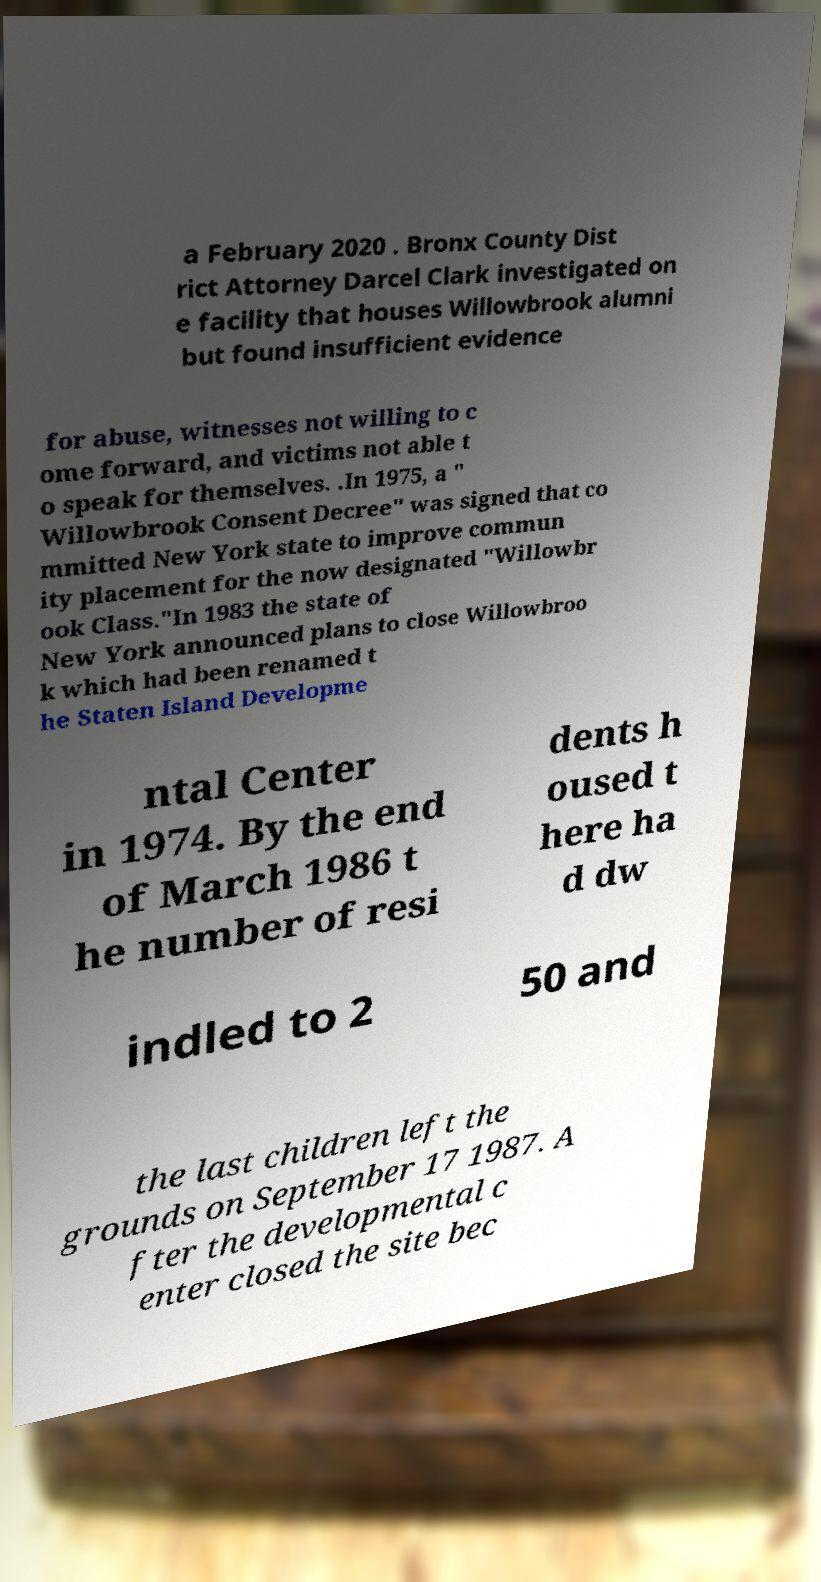There's text embedded in this image that I need extracted. Can you transcribe it verbatim? a February 2020 . Bronx County Dist rict Attorney Darcel Clark investigated on e facility that houses Willowbrook alumni but found insufficient evidence for abuse, witnesses not willing to c ome forward, and victims not able t o speak for themselves. .In 1975, a " Willowbrook Consent Decree" was signed that co mmitted New York state to improve commun ity placement for the now designated "Willowbr ook Class."In 1983 the state of New York announced plans to close Willowbroo k which had been renamed t he Staten Island Developme ntal Center in 1974. By the end of March 1986 t he number of resi dents h oused t here ha d dw indled to 2 50 and the last children left the grounds on September 17 1987. A fter the developmental c enter closed the site bec 